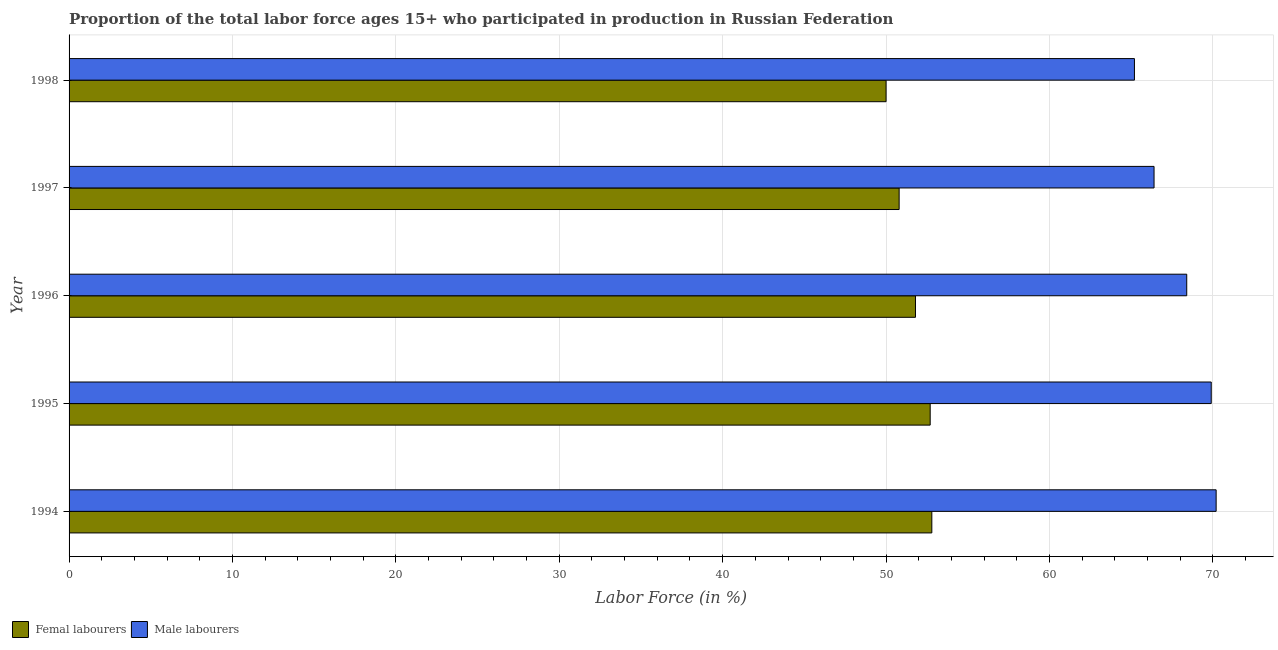How many different coloured bars are there?
Offer a terse response. 2. How many groups of bars are there?
Ensure brevity in your answer.  5. How many bars are there on the 5th tick from the top?
Keep it short and to the point. 2. How many bars are there on the 5th tick from the bottom?
Your answer should be compact. 2. What is the label of the 3rd group of bars from the top?
Your answer should be compact. 1996. What is the percentage of female labor force in 1997?
Your answer should be very brief. 50.8. Across all years, what is the maximum percentage of male labour force?
Your response must be concise. 70.2. Across all years, what is the minimum percentage of female labor force?
Give a very brief answer. 50. In which year was the percentage of female labor force minimum?
Provide a succinct answer. 1998. What is the total percentage of female labor force in the graph?
Provide a succinct answer. 258.1. What is the difference between the percentage of male labour force in 1996 and the percentage of female labor force in 1997?
Your answer should be compact. 17.6. What is the average percentage of female labor force per year?
Your answer should be very brief. 51.62. In the year 1995, what is the difference between the percentage of male labour force and percentage of female labor force?
Make the answer very short. 17.2. What is the ratio of the percentage of male labour force in 1995 to that in 1998?
Your response must be concise. 1.07. Is the percentage of female labor force in 1995 less than that in 1997?
Your response must be concise. No. Is the difference between the percentage of male labour force in 1997 and 1998 greater than the difference between the percentage of female labor force in 1997 and 1998?
Your response must be concise. Yes. What is the difference between the highest and the second highest percentage of female labor force?
Your response must be concise. 0.1. In how many years, is the percentage of male labour force greater than the average percentage of male labour force taken over all years?
Keep it short and to the point. 3. What does the 1st bar from the top in 1998 represents?
Give a very brief answer. Male labourers. What does the 1st bar from the bottom in 1996 represents?
Ensure brevity in your answer.  Femal labourers. Are all the bars in the graph horizontal?
Give a very brief answer. Yes. How many years are there in the graph?
Your response must be concise. 5. Does the graph contain grids?
Provide a short and direct response. Yes. What is the title of the graph?
Give a very brief answer. Proportion of the total labor force ages 15+ who participated in production in Russian Federation. What is the label or title of the X-axis?
Provide a short and direct response. Labor Force (in %). What is the label or title of the Y-axis?
Provide a short and direct response. Year. What is the Labor Force (in %) in Femal labourers in 1994?
Your answer should be very brief. 52.8. What is the Labor Force (in %) in Male labourers in 1994?
Provide a short and direct response. 70.2. What is the Labor Force (in %) of Femal labourers in 1995?
Offer a terse response. 52.7. What is the Labor Force (in %) in Male labourers in 1995?
Keep it short and to the point. 69.9. What is the Labor Force (in %) in Femal labourers in 1996?
Your answer should be compact. 51.8. What is the Labor Force (in %) in Male labourers in 1996?
Ensure brevity in your answer.  68.4. What is the Labor Force (in %) of Femal labourers in 1997?
Offer a terse response. 50.8. What is the Labor Force (in %) of Male labourers in 1997?
Offer a terse response. 66.4. What is the Labor Force (in %) of Femal labourers in 1998?
Provide a short and direct response. 50. What is the Labor Force (in %) of Male labourers in 1998?
Keep it short and to the point. 65.2. Across all years, what is the maximum Labor Force (in %) in Femal labourers?
Your answer should be compact. 52.8. Across all years, what is the maximum Labor Force (in %) in Male labourers?
Offer a terse response. 70.2. Across all years, what is the minimum Labor Force (in %) of Femal labourers?
Your answer should be compact. 50. Across all years, what is the minimum Labor Force (in %) in Male labourers?
Make the answer very short. 65.2. What is the total Labor Force (in %) of Femal labourers in the graph?
Provide a succinct answer. 258.1. What is the total Labor Force (in %) of Male labourers in the graph?
Offer a terse response. 340.1. What is the difference between the Labor Force (in %) of Femal labourers in 1994 and that in 1995?
Keep it short and to the point. 0.1. What is the difference between the Labor Force (in %) of Male labourers in 1994 and that in 1995?
Ensure brevity in your answer.  0.3. What is the difference between the Labor Force (in %) in Femal labourers in 1994 and that in 1997?
Your response must be concise. 2. What is the difference between the Labor Force (in %) of Male labourers in 1995 and that in 1996?
Provide a short and direct response. 1.5. What is the difference between the Labor Force (in %) of Male labourers in 1995 and that in 1998?
Your answer should be compact. 4.7. What is the difference between the Labor Force (in %) in Male labourers in 1996 and that in 1997?
Provide a succinct answer. 2. What is the difference between the Labor Force (in %) of Male labourers in 1996 and that in 1998?
Offer a very short reply. 3.2. What is the difference between the Labor Force (in %) in Male labourers in 1997 and that in 1998?
Provide a short and direct response. 1.2. What is the difference between the Labor Force (in %) of Femal labourers in 1994 and the Labor Force (in %) of Male labourers in 1995?
Ensure brevity in your answer.  -17.1. What is the difference between the Labor Force (in %) of Femal labourers in 1994 and the Labor Force (in %) of Male labourers in 1996?
Your response must be concise. -15.6. What is the difference between the Labor Force (in %) of Femal labourers in 1994 and the Labor Force (in %) of Male labourers in 1997?
Offer a terse response. -13.6. What is the difference between the Labor Force (in %) of Femal labourers in 1994 and the Labor Force (in %) of Male labourers in 1998?
Your answer should be very brief. -12.4. What is the difference between the Labor Force (in %) of Femal labourers in 1995 and the Labor Force (in %) of Male labourers in 1996?
Provide a short and direct response. -15.7. What is the difference between the Labor Force (in %) of Femal labourers in 1995 and the Labor Force (in %) of Male labourers in 1997?
Keep it short and to the point. -13.7. What is the difference between the Labor Force (in %) of Femal labourers in 1995 and the Labor Force (in %) of Male labourers in 1998?
Your response must be concise. -12.5. What is the difference between the Labor Force (in %) of Femal labourers in 1996 and the Labor Force (in %) of Male labourers in 1997?
Provide a succinct answer. -14.6. What is the difference between the Labor Force (in %) of Femal labourers in 1997 and the Labor Force (in %) of Male labourers in 1998?
Your response must be concise. -14.4. What is the average Labor Force (in %) in Femal labourers per year?
Offer a terse response. 51.62. What is the average Labor Force (in %) of Male labourers per year?
Offer a terse response. 68.02. In the year 1994, what is the difference between the Labor Force (in %) in Femal labourers and Labor Force (in %) in Male labourers?
Offer a very short reply. -17.4. In the year 1995, what is the difference between the Labor Force (in %) in Femal labourers and Labor Force (in %) in Male labourers?
Offer a very short reply. -17.2. In the year 1996, what is the difference between the Labor Force (in %) in Femal labourers and Labor Force (in %) in Male labourers?
Offer a very short reply. -16.6. In the year 1997, what is the difference between the Labor Force (in %) in Femal labourers and Labor Force (in %) in Male labourers?
Your answer should be compact. -15.6. In the year 1998, what is the difference between the Labor Force (in %) of Femal labourers and Labor Force (in %) of Male labourers?
Your response must be concise. -15.2. What is the ratio of the Labor Force (in %) of Femal labourers in 1994 to that in 1995?
Keep it short and to the point. 1. What is the ratio of the Labor Force (in %) in Male labourers in 1994 to that in 1995?
Give a very brief answer. 1. What is the ratio of the Labor Force (in %) in Femal labourers in 1994 to that in 1996?
Offer a terse response. 1.02. What is the ratio of the Labor Force (in %) in Male labourers in 1994 to that in 1996?
Offer a terse response. 1.03. What is the ratio of the Labor Force (in %) in Femal labourers in 1994 to that in 1997?
Provide a short and direct response. 1.04. What is the ratio of the Labor Force (in %) of Male labourers in 1994 to that in 1997?
Provide a short and direct response. 1.06. What is the ratio of the Labor Force (in %) in Femal labourers in 1994 to that in 1998?
Provide a succinct answer. 1.06. What is the ratio of the Labor Force (in %) of Male labourers in 1994 to that in 1998?
Ensure brevity in your answer.  1.08. What is the ratio of the Labor Force (in %) in Femal labourers in 1995 to that in 1996?
Ensure brevity in your answer.  1.02. What is the ratio of the Labor Force (in %) of Male labourers in 1995 to that in 1996?
Offer a terse response. 1.02. What is the ratio of the Labor Force (in %) in Femal labourers in 1995 to that in 1997?
Your answer should be very brief. 1.04. What is the ratio of the Labor Force (in %) of Male labourers in 1995 to that in 1997?
Offer a terse response. 1.05. What is the ratio of the Labor Force (in %) of Femal labourers in 1995 to that in 1998?
Make the answer very short. 1.05. What is the ratio of the Labor Force (in %) in Male labourers in 1995 to that in 1998?
Offer a very short reply. 1.07. What is the ratio of the Labor Force (in %) of Femal labourers in 1996 to that in 1997?
Give a very brief answer. 1.02. What is the ratio of the Labor Force (in %) in Male labourers in 1996 to that in 1997?
Make the answer very short. 1.03. What is the ratio of the Labor Force (in %) in Femal labourers in 1996 to that in 1998?
Offer a very short reply. 1.04. What is the ratio of the Labor Force (in %) in Male labourers in 1996 to that in 1998?
Provide a succinct answer. 1.05. What is the ratio of the Labor Force (in %) in Male labourers in 1997 to that in 1998?
Make the answer very short. 1.02. What is the difference between the highest and the second highest Labor Force (in %) in Femal labourers?
Your response must be concise. 0.1. What is the difference between the highest and the lowest Labor Force (in %) in Femal labourers?
Ensure brevity in your answer.  2.8. What is the difference between the highest and the lowest Labor Force (in %) in Male labourers?
Keep it short and to the point. 5. 